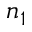Convert formula to latex. <formula><loc_0><loc_0><loc_500><loc_500>n _ { 1 }</formula> 